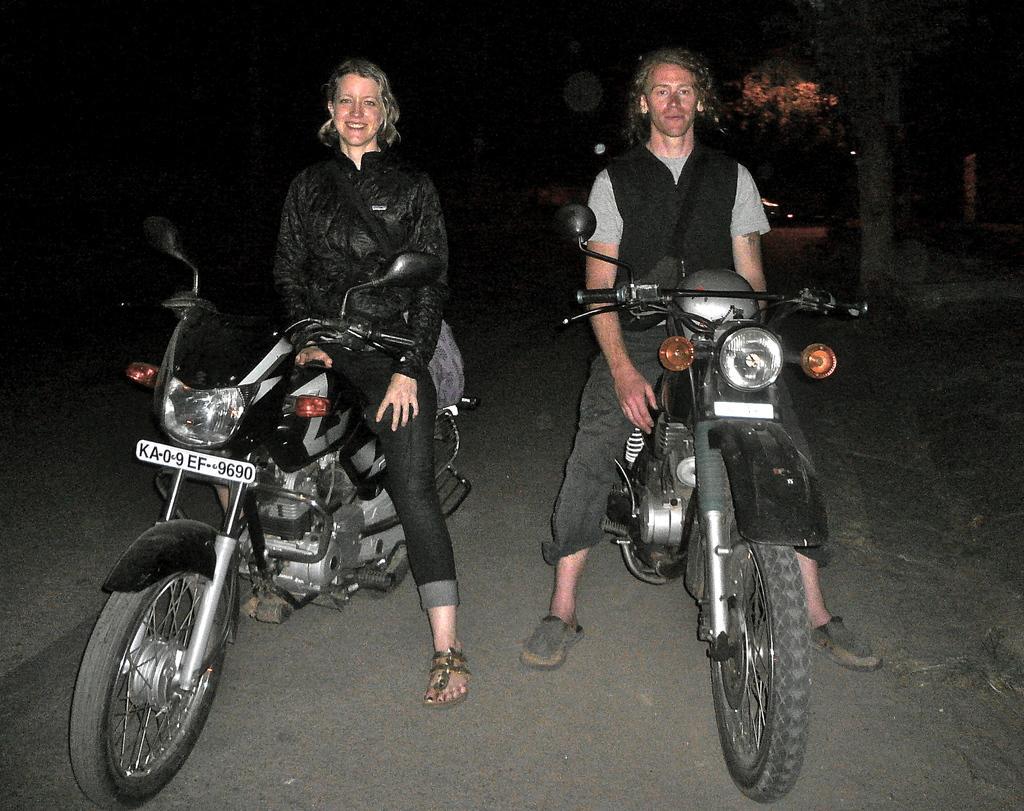Can you describe this image briefly? There are two members sitting on the bikes on the road. One is woman and the other is man. Woman is smiling. In the background there are some trees. 